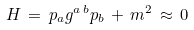Convert formula to latex. <formula><loc_0><loc_0><loc_500><loc_500>H \, = \, p _ { a } g ^ { a \, b } p _ { b } \, + \, m ^ { 2 } \, \approx \, 0</formula> 